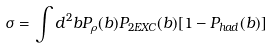Convert formula to latex. <formula><loc_0><loc_0><loc_500><loc_500>\sigma = \int d ^ { 2 } b P _ { \rho } ( b ) P _ { 2 E X C } ( b ) [ 1 - P _ { h a d } ( b ) ]</formula> 